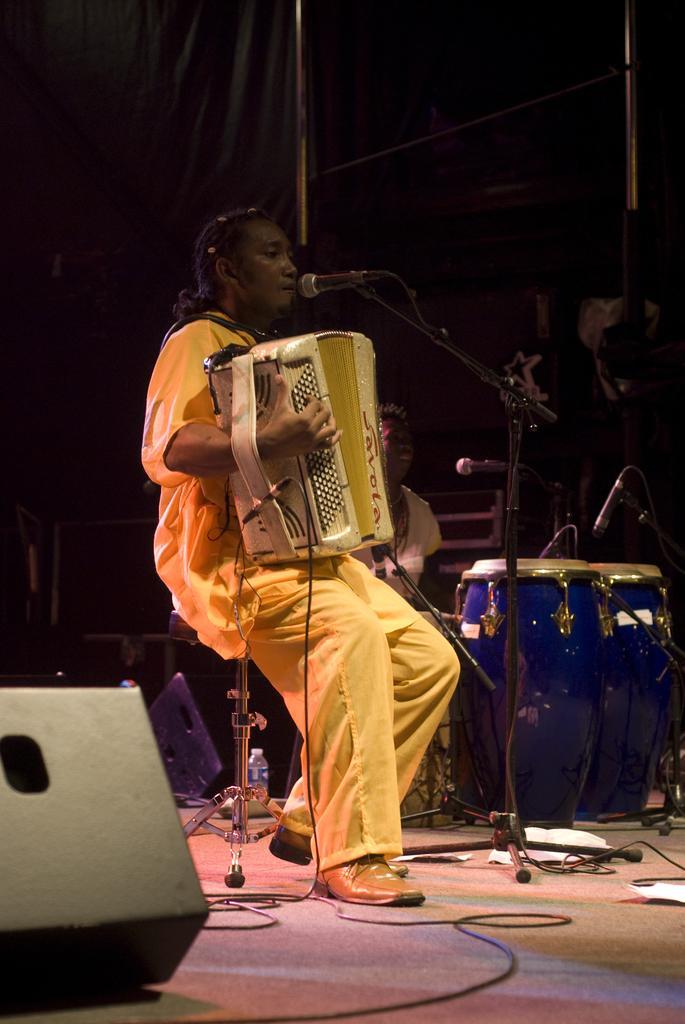Could you give a brief overview of what you see in this image? A person is sitting on a chair by playing musical instrument and singing on mic which is on a stand on the floor and there is an object,drums,cables and other musical instruments on the floor. In the background image is dark but we can see objects. 